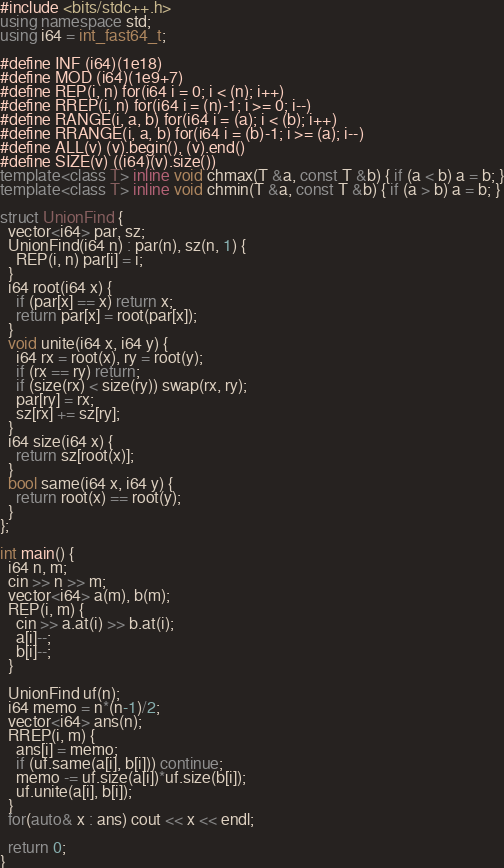<code> <loc_0><loc_0><loc_500><loc_500><_C++_>#include <bits/stdc++.h>
using namespace std;
using i64 = int_fast64_t;

#define INF (i64)(1e18)
#define MOD (i64)(1e9+7)
#define REP(i, n) for(i64 i = 0; i < (n); i++)
#define RREP(i, n) for(i64 i = (n)-1; i >= 0; i--)
#define RANGE(i, a, b) for(i64 i = (a); i < (b); i++)
#define RRANGE(i, a, b) for(i64 i = (b)-1; i >= (a); i--)
#define ALL(v) (v).begin(), (v).end()
#define SIZE(v) ((i64)(v).size())
template<class T> inline void chmax(T &a, const T &b) { if (a < b) a = b; }
template<class T> inline void chmin(T &a, const T &b) { if (a > b) a = b; }

struct UnionFind {
  vector<i64> par, sz;
  UnionFind(i64 n) : par(n), sz(n, 1) {
    REP(i, n) par[i] = i;
  }
  i64 root(i64 x) {
    if (par[x] == x) return x;
    return par[x] = root(par[x]);
  }
  void unite(i64 x, i64 y) {
    i64 rx = root(x), ry = root(y);
    if (rx == ry) return;
    if (size(rx) < size(ry)) swap(rx, ry);
    par[ry] = rx;
    sz[rx] += sz[ry];
  }
  i64 size(i64 x) {
    return sz[root(x)];
  }
  bool same(i64 x, i64 y) {
    return root(x) == root(y);
  }
};

int main() {
  i64 n, m;
  cin >> n >> m;
  vector<i64> a(m), b(m);
  REP(i, m) {
    cin >> a.at(i) >> b.at(i);
    a[i]--;
    b[i]--;
  }

  UnionFind uf(n);
  i64 memo = n*(n-1)/2;
  vector<i64> ans(n);
  RREP(i, m) {
    ans[i] = memo;
    if (uf.same(a[i], b[i])) continue;
    memo -= uf.size(a[i])*uf.size(b[i]);
    uf.unite(a[i], b[i]);
  }
  for(auto& x : ans) cout << x << endl;

  return 0;
}
</code> 